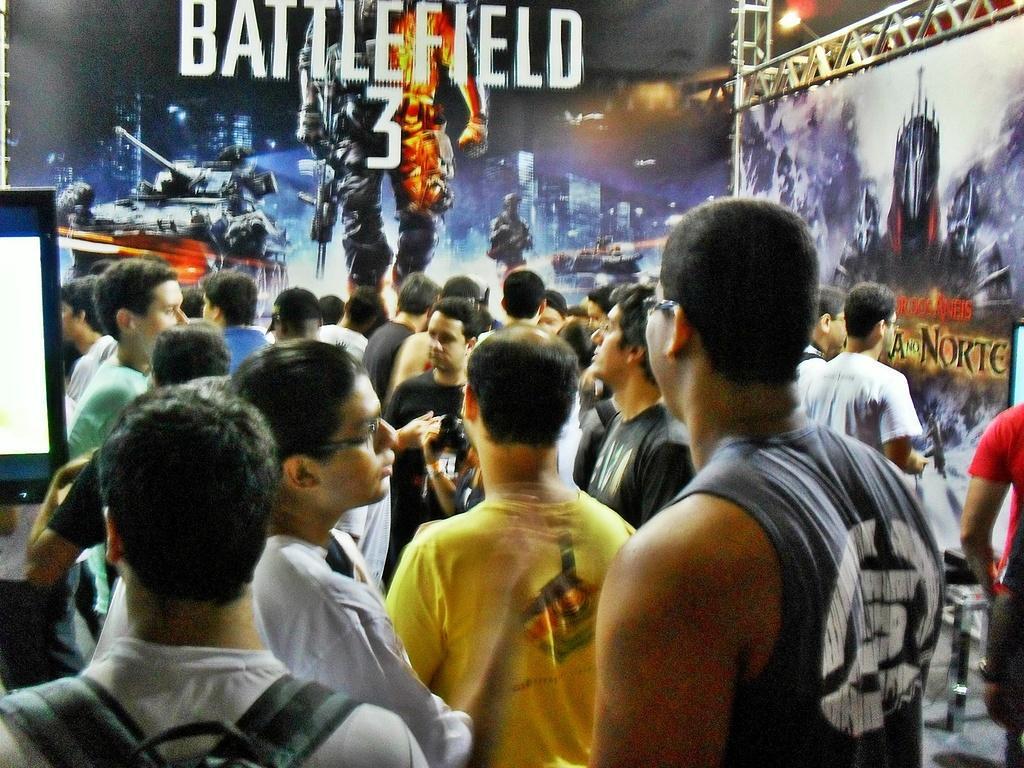In one or two sentences, can you explain what this image depicts? In this image, we can see a group of people. On the left side, we can see a monitor screen. Background we can see posters, rods. 